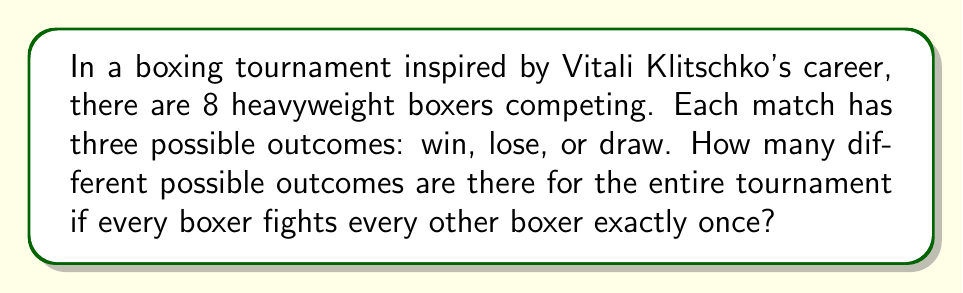Teach me how to tackle this problem. Let's approach this step-by-step:

1) First, we need to calculate the total number of matches in the tournament:
   - With 8 boxers, each boxer fights 7 others
   - Total matches = $(8 \times 7) / 2 = 28$ (we divide by 2 to avoid counting each match twice)

2) For each match, there are 3 possible outcomes (win, lose, or draw)

3) To find the total number of possible outcomes for the entire tournament, we use the multiplication principle:
   - Each match is independent, so we multiply the number of possibilities for each match
   - This gives us $3^{28}$, as we have 3 choices for each of the 28 matches

4) Therefore, the total number of possible outcomes is:

   $$3^{28} = 22,876,792,454,961$$

This incredibly large number showcases the complexity and unpredictability of a boxing tournament, much like the excitement Vitali Klitschko brought to his matches throughout his career.
Answer: $3^{28}$ 